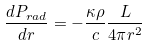<formula> <loc_0><loc_0><loc_500><loc_500>\frac { d P _ { r a d } } { d r } = - \frac { \kappa \rho } { c } \frac { L } { 4 \pi r ^ { 2 } }</formula> 